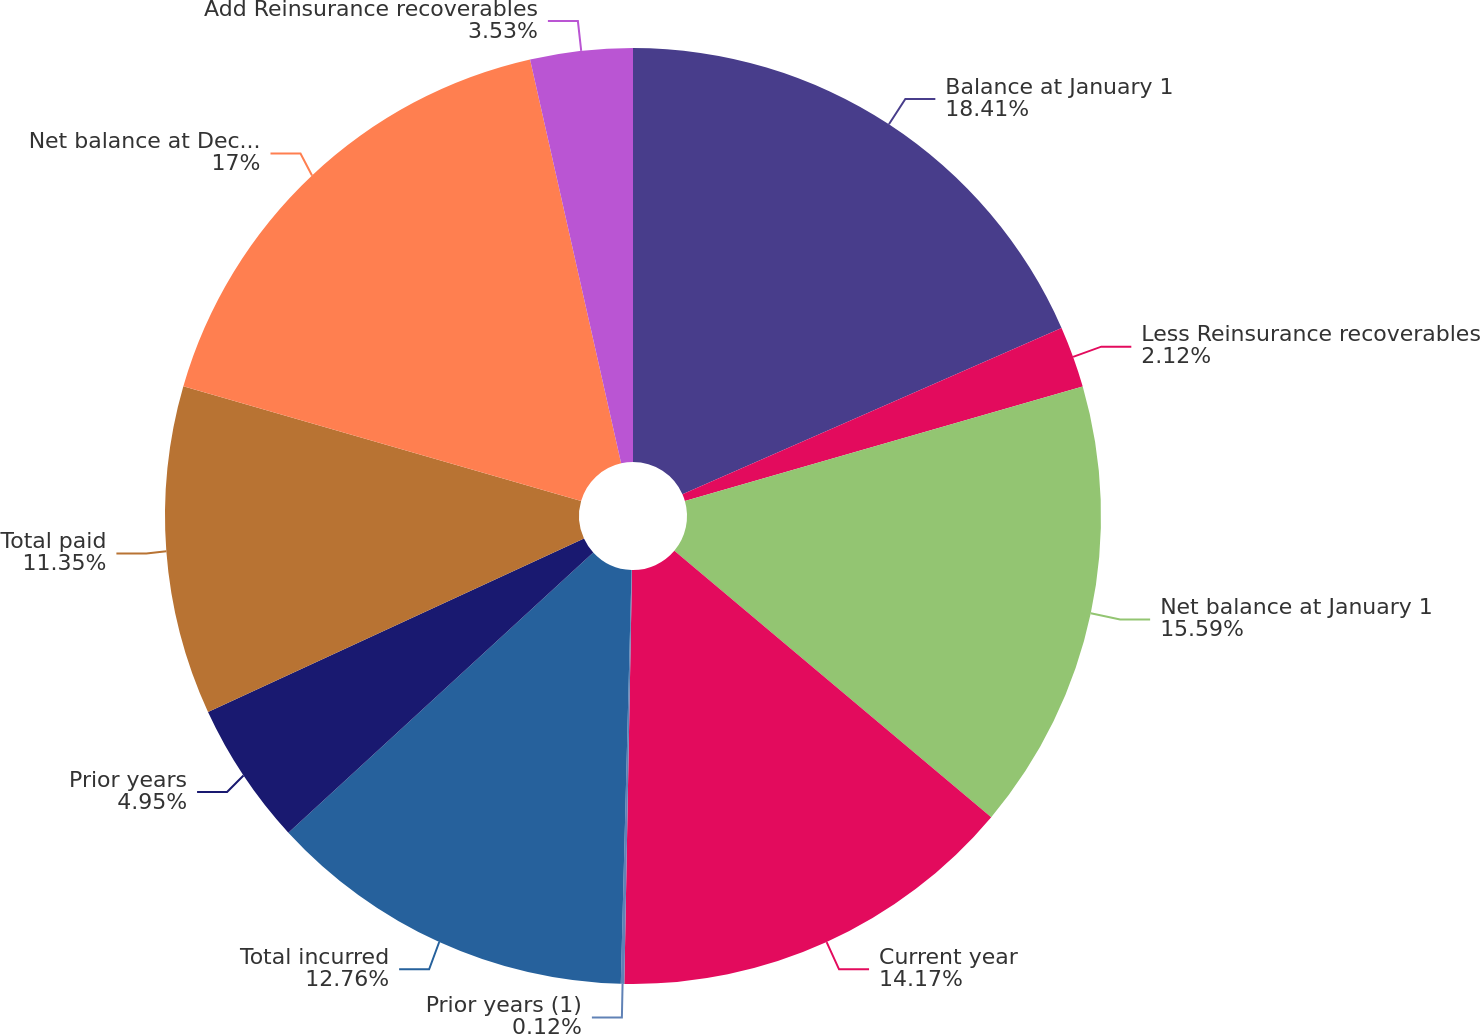<chart> <loc_0><loc_0><loc_500><loc_500><pie_chart><fcel>Balance at January 1<fcel>Less Reinsurance recoverables<fcel>Net balance at January 1<fcel>Current year<fcel>Prior years (1)<fcel>Total incurred<fcel>Prior years<fcel>Total paid<fcel>Net balance at December 31<fcel>Add Reinsurance recoverables<nl><fcel>18.42%<fcel>2.12%<fcel>15.59%<fcel>14.17%<fcel>0.12%<fcel>12.76%<fcel>4.95%<fcel>11.35%<fcel>17.0%<fcel>3.53%<nl></chart> 